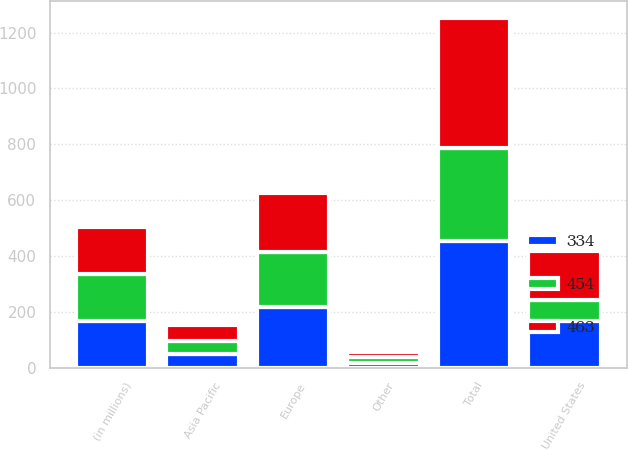<chart> <loc_0><loc_0><loc_500><loc_500><stacked_bar_chart><ecel><fcel>(in millions)<fcel>United States<fcel>Europe<fcel>Asia Pacific<fcel>Other<fcel>Total<nl><fcel>463<fcel>168<fcel>178<fcel>209<fcel>57<fcel>19<fcel>463<nl><fcel>334<fcel>168<fcel>168<fcel>219<fcel>49<fcel>18<fcel>454<nl><fcel>454<fcel>168<fcel>73<fcel>196<fcel>46<fcel>19<fcel>334<nl></chart> 